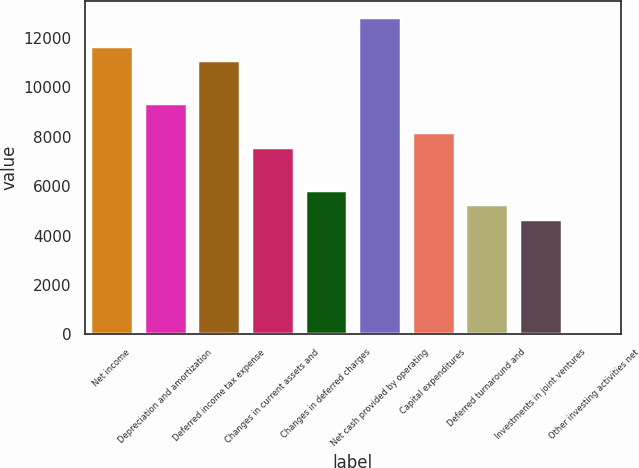Convert chart to OTSL. <chart><loc_0><loc_0><loc_500><loc_500><bar_chart><fcel>Net income<fcel>Depreciation and amortization<fcel>Deferred income tax expense<fcel>Changes in current assets and<fcel>Changes in deferred charges<fcel>Net cash provided by operating<fcel>Capital expenditures<fcel>Deferred turnaround and<fcel>Investments in joint ventures<fcel>Other investing activities net<nl><fcel>11698<fcel>9358.8<fcel>11113.2<fcel>7604.4<fcel>5850<fcel>12867.6<fcel>8189.2<fcel>5265.2<fcel>4680.4<fcel>2<nl></chart> 